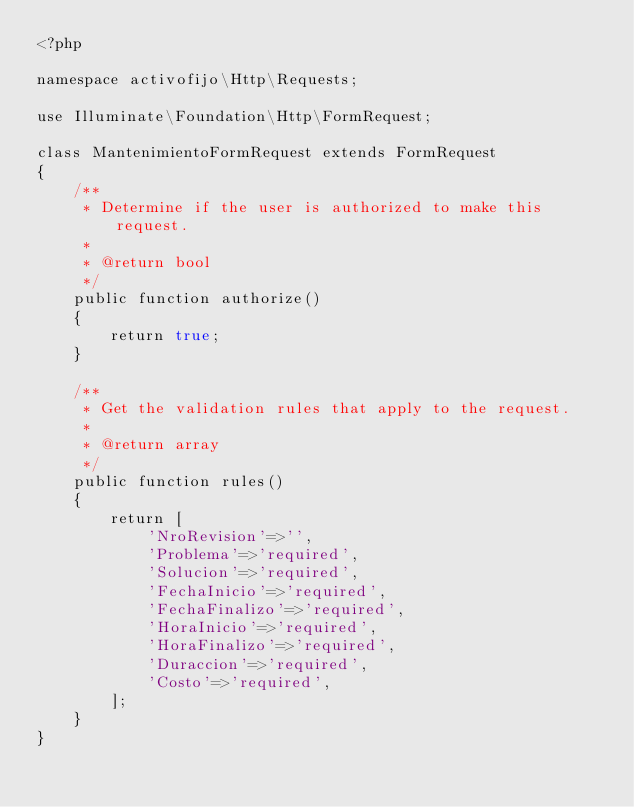Convert code to text. <code><loc_0><loc_0><loc_500><loc_500><_PHP_><?php

namespace activofijo\Http\Requests;

use Illuminate\Foundation\Http\FormRequest;

class MantenimientoFormRequest extends FormRequest
{
    /**
     * Determine if the user is authorized to make this request.
     *
     * @return bool
     */
    public function authorize()
    {
        return true;
    }

    /**
     * Get the validation rules that apply to the request.
     *
     * @return array
     */
    public function rules()
    {
        return [
            'NroRevision'=>'',
            'Problema'=>'required',
            'Solucion'=>'required',
            'FechaInicio'=>'required',
            'FechaFinalizo'=>'required',
            'HoraInicio'=>'required',
            'HoraFinalizo'=>'required',
            'Duraccion'=>'required',
            'Costo'=>'required',
        ];
    }
}
</code> 